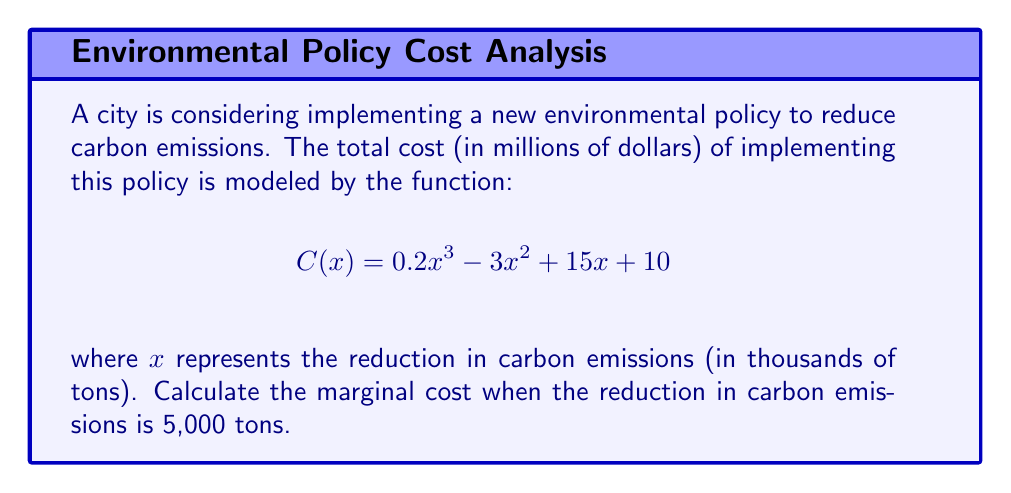Give your solution to this math problem. To solve this problem, we need to follow these steps:

1) The marginal cost is represented by the derivative of the total cost function. So, we need to find $C'(x)$.

2) Let's differentiate $C(x)$ term by term:
   
   $$C'(x) = 0.6x^2 - 6x + 15$$

3) We're asked to find the marginal cost when the reduction in carbon emissions is 5,000 tons. In the function, $x$ is in thousands of tons, so we need to use $x = 5$.

4) Now, let's substitute $x = 5$ into our derivative function:

   $$C'(5) = 0.6(5)^2 - 6(5) + 15$$

5) Let's calculate this:
   
   $$C'(5) = 0.6(25) - 30 + 15$$
   $$C'(5) = 15 - 30 + 15 = 0$$

6) The result is in millions of dollars, as specified in the original function.
Answer: $0 million 